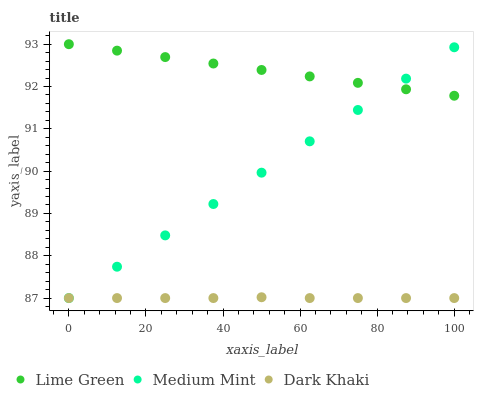Does Dark Khaki have the minimum area under the curve?
Answer yes or no. Yes. Does Lime Green have the maximum area under the curve?
Answer yes or no. Yes. Does Lime Green have the minimum area under the curve?
Answer yes or no. No. Does Dark Khaki have the maximum area under the curve?
Answer yes or no. No. Is Lime Green the smoothest?
Answer yes or no. Yes. Is Dark Khaki the roughest?
Answer yes or no. Yes. Is Dark Khaki the smoothest?
Answer yes or no. No. Is Lime Green the roughest?
Answer yes or no. No. Does Medium Mint have the lowest value?
Answer yes or no. Yes. Does Lime Green have the lowest value?
Answer yes or no. No. Does Lime Green have the highest value?
Answer yes or no. Yes. Does Dark Khaki have the highest value?
Answer yes or no. No. Is Dark Khaki less than Lime Green?
Answer yes or no. Yes. Is Lime Green greater than Dark Khaki?
Answer yes or no. Yes. Does Medium Mint intersect Dark Khaki?
Answer yes or no. Yes. Is Medium Mint less than Dark Khaki?
Answer yes or no. No. Is Medium Mint greater than Dark Khaki?
Answer yes or no. No. Does Dark Khaki intersect Lime Green?
Answer yes or no. No. 